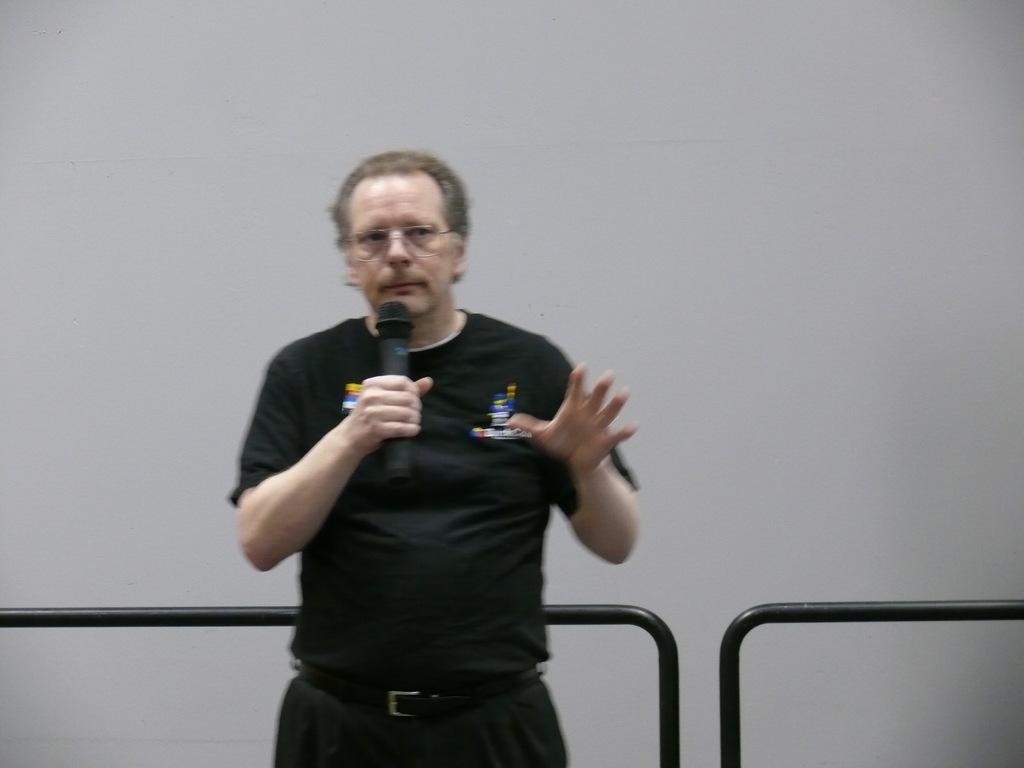Please provide a concise description of this image. As we can see in the image there is white color wall, a man wearing black color t shirt and holding mic. 